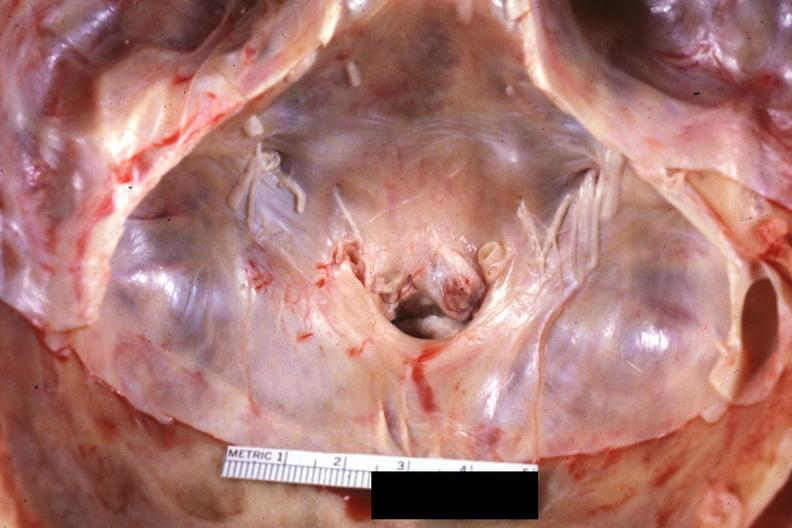what does this image show?
Answer the question using a single word or phrase. Close-up of foramen magnum stenosis due to subluxation of atlas vertebra case 31 